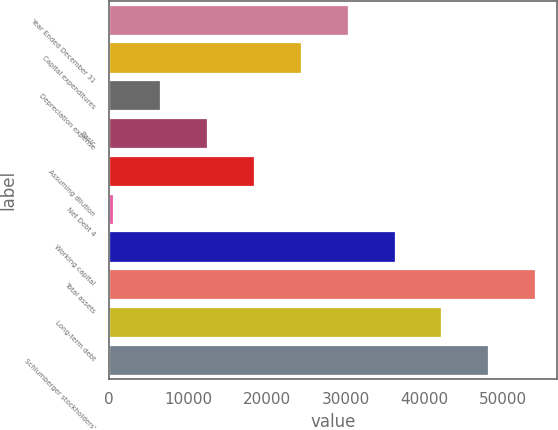Convert chart. <chart><loc_0><loc_0><loc_500><loc_500><bar_chart><fcel>Year Ended December 31<fcel>Capital expenditures<fcel>Depreciation expense<fcel>Basic<fcel>Assuming dilution<fcel>Net Debt 4<fcel>Working capital<fcel>Total assets<fcel>Long-term debt<fcel>Schlumberger stockholders'<nl><fcel>30266<fcel>24319.2<fcel>6478.8<fcel>12425.6<fcel>18372.4<fcel>532<fcel>36212.8<fcel>54053.2<fcel>42159.6<fcel>48106.4<nl></chart> 